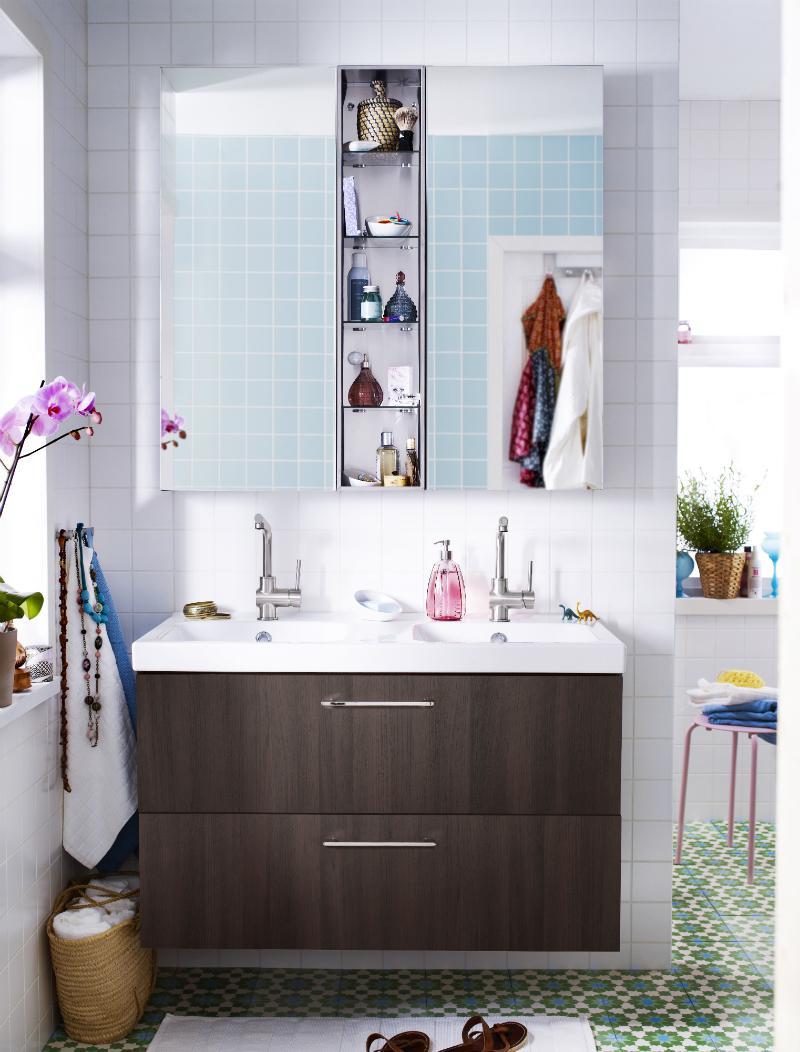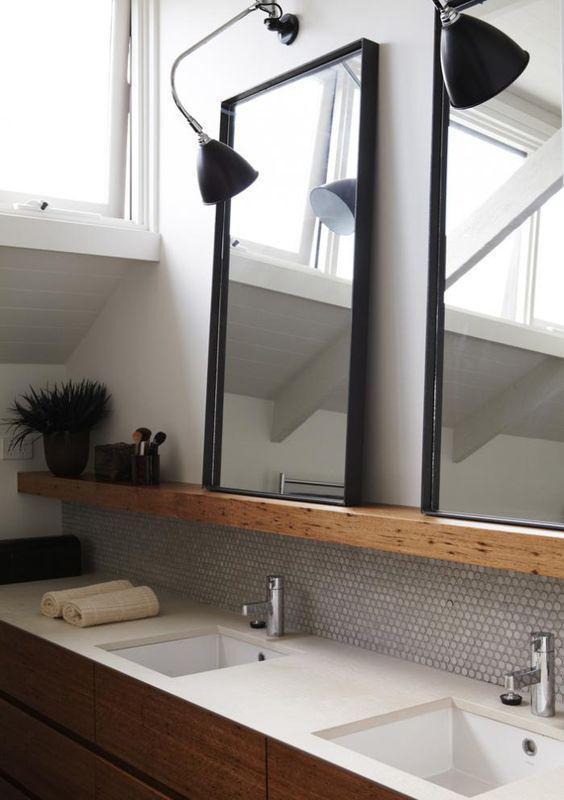The first image is the image on the left, the second image is the image on the right. For the images displayed, is the sentence "In one image, a wide footed vanity has two matching sinks mounted on top of the vanity and a one large mirror on the wall behind it." factually correct? Answer yes or no. No. 